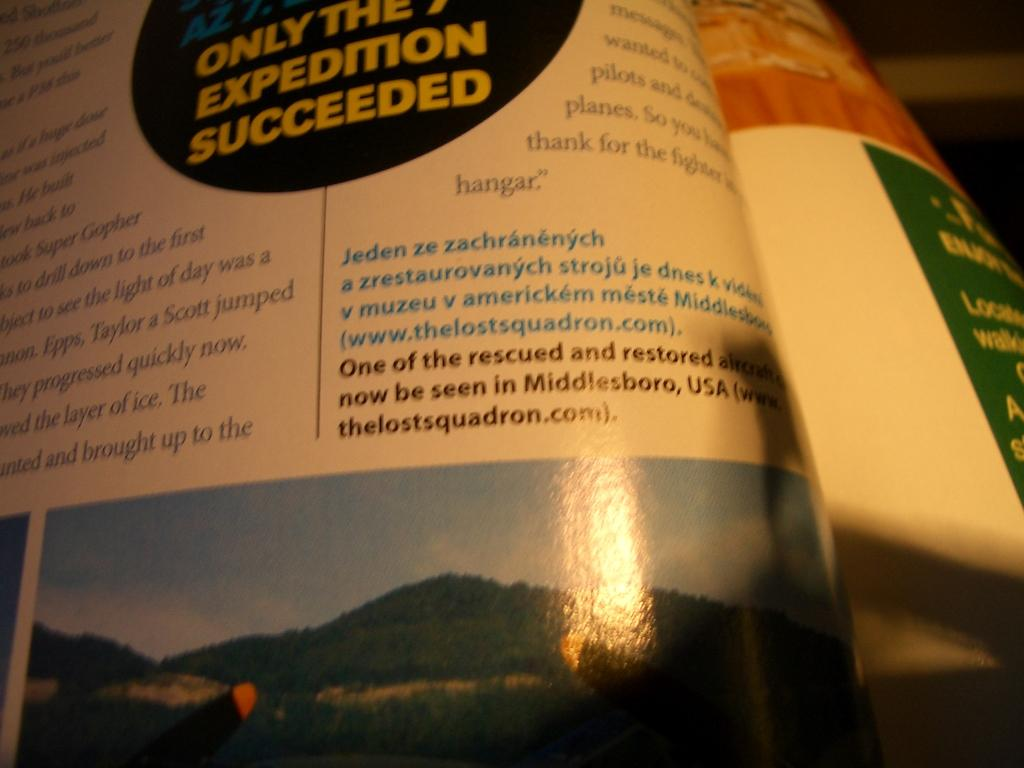<image>
Relay a brief, clear account of the picture shown. A book opened to a page with a blurb that only the expedition succeeded. 